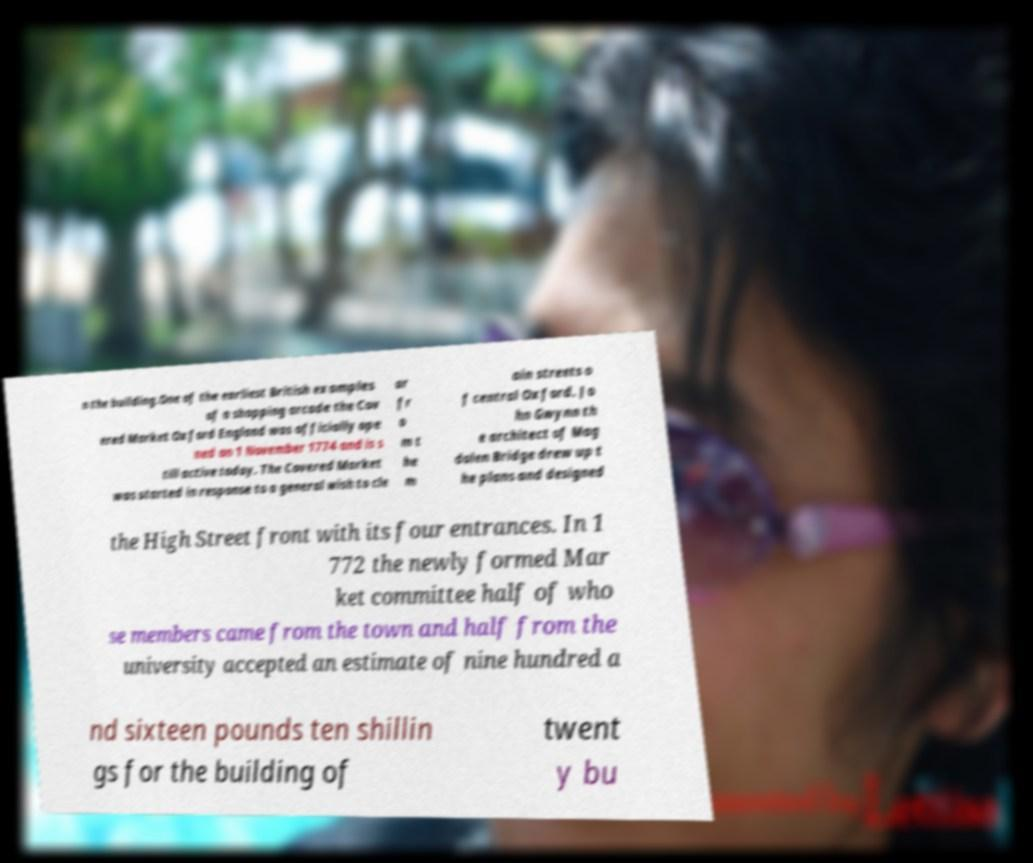Please identify and transcribe the text found in this image. n the building.One of the earliest British examples of a shopping arcade the Cov ered Market Oxford England was officially ope ned on 1 November 1774 and is s till active today. The Covered Market was started in response to a general wish to cle ar fr o m t he m ain streets o f central Oxford. Jo hn Gwynn th e architect of Mag dalen Bridge drew up t he plans and designed the High Street front with its four entrances. In 1 772 the newly formed Mar ket committee half of who se members came from the town and half from the university accepted an estimate of nine hundred a nd sixteen pounds ten shillin gs for the building of twent y bu 